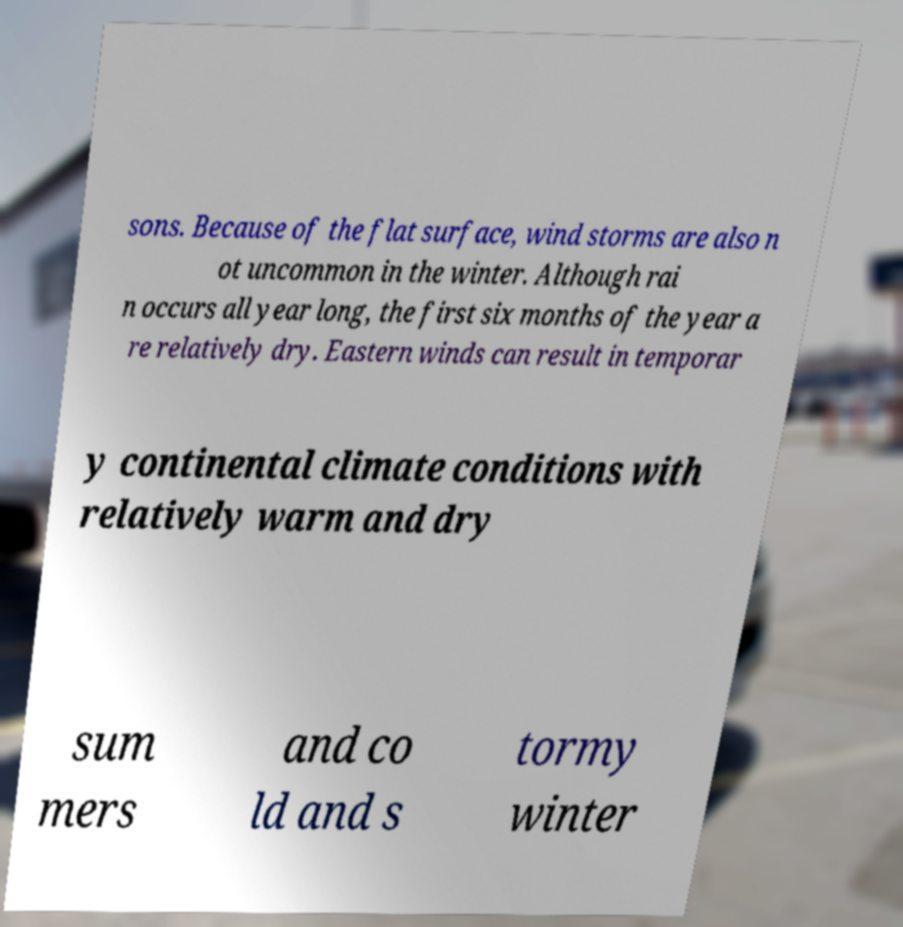There's text embedded in this image that I need extracted. Can you transcribe it verbatim? sons. Because of the flat surface, wind storms are also n ot uncommon in the winter. Although rai n occurs all year long, the first six months of the year a re relatively dry. Eastern winds can result in temporar y continental climate conditions with relatively warm and dry sum mers and co ld and s tormy winter 